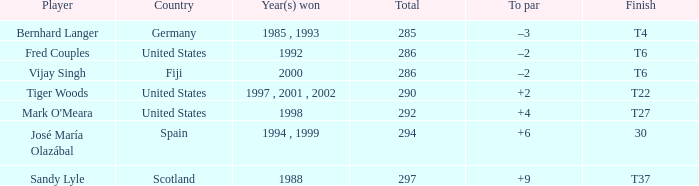Which player has a total of more than 290 and +4 to par. Mark O'Meara. 